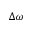<formula> <loc_0><loc_0><loc_500><loc_500>\Delta \omega</formula> 